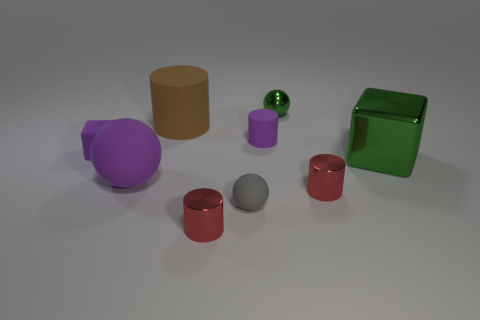There is a large thing that is the same color as the tiny metallic sphere; what is its material?
Your answer should be very brief. Metal. There is a green thing in front of the small cylinder behind the purple block; is there a green thing in front of it?
Make the answer very short. No. Are there fewer large purple rubber spheres to the right of the green metallic ball than blocks to the right of the gray ball?
Provide a succinct answer. Yes. What color is the large cylinder that is the same material as the large purple thing?
Your answer should be very brief. Brown. There is a matte ball on the left side of the big cylinder behind the purple ball; what color is it?
Your response must be concise. Purple. Are there any things of the same color as the large matte sphere?
Offer a terse response. Yes. The green metal thing that is the same size as the purple rubber cube is what shape?
Offer a very short reply. Sphere. How many small red cylinders are behind the large object that is behind the big cube?
Provide a short and direct response. 0. Is the small metal sphere the same color as the large block?
Give a very brief answer. Yes. How many other objects are there of the same material as the brown thing?
Keep it short and to the point. 4. 